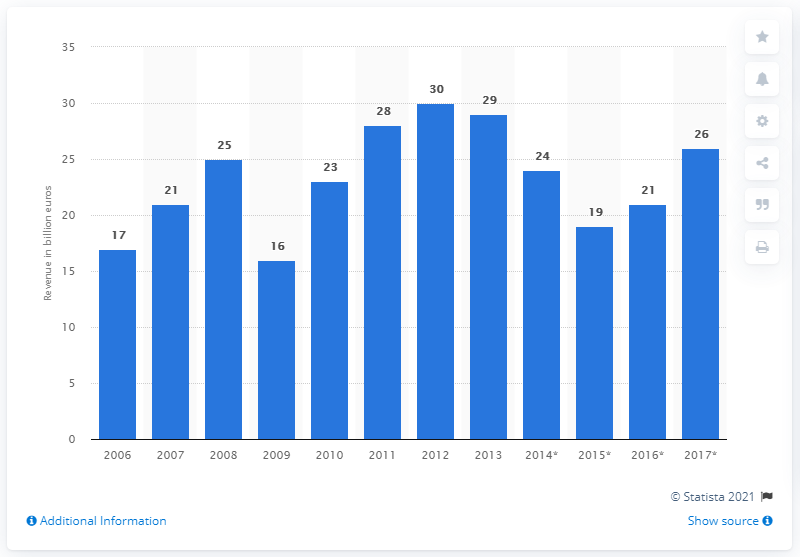Highlight a few significant elements in this photo. According to estimates, the mechanical engineering industry in Russia generated an estimated revenue of approximately 26 billion USD in 2017. 